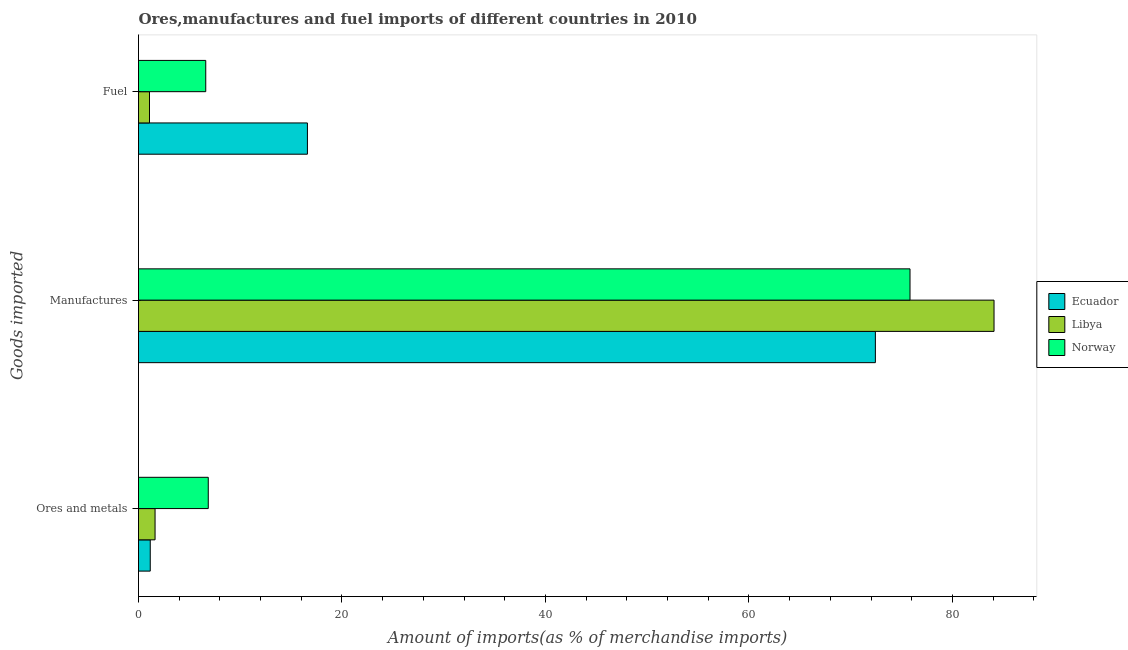How many different coloured bars are there?
Your answer should be very brief. 3. How many groups of bars are there?
Offer a terse response. 3. How many bars are there on the 2nd tick from the top?
Ensure brevity in your answer.  3. What is the label of the 2nd group of bars from the top?
Give a very brief answer. Manufactures. What is the percentage of ores and metals imports in Libya?
Your answer should be compact. 1.63. Across all countries, what is the maximum percentage of fuel imports?
Your answer should be compact. 16.6. Across all countries, what is the minimum percentage of manufactures imports?
Your answer should be very brief. 72.43. In which country was the percentage of fuel imports maximum?
Make the answer very short. Ecuador. In which country was the percentage of ores and metals imports minimum?
Make the answer very short. Ecuador. What is the total percentage of ores and metals imports in the graph?
Offer a very short reply. 9.64. What is the difference between the percentage of ores and metals imports in Libya and that in Ecuador?
Ensure brevity in your answer.  0.47. What is the difference between the percentage of manufactures imports in Libya and the percentage of fuel imports in Ecuador?
Offer a terse response. 67.49. What is the average percentage of manufactures imports per country?
Give a very brief answer. 77.45. What is the difference between the percentage of fuel imports and percentage of manufactures imports in Ecuador?
Your answer should be compact. -55.83. In how many countries, is the percentage of fuel imports greater than 16 %?
Give a very brief answer. 1. What is the ratio of the percentage of ores and metals imports in Ecuador to that in Libya?
Give a very brief answer. 0.71. Is the difference between the percentage of manufactures imports in Norway and Libya greater than the difference between the percentage of ores and metals imports in Norway and Libya?
Keep it short and to the point. No. What is the difference between the highest and the second highest percentage of fuel imports?
Give a very brief answer. 9.99. What is the difference between the highest and the lowest percentage of manufactures imports?
Ensure brevity in your answer.  11.66. In how many countries, is the percentage of manufactures imports greater than the average percentage of manufactures imports taken over all countries?
Make the answer very short. 1. What does the 2nd bar from the top in Ores and metals represents?
Give a very brief answer. Libya. What does the 1st bar from the bottom in Manufactures represents?
Provide a short and direct response. Ecuador. Is it the case that in every country, the sum of the percentage of ores and metals imports and percentage of manufactures imports is greater than the percentage of fuel imports?
Provide a short and direct response. Yes. Are all the bars in the graph horizontal?
Offer a very short reply. Yes. How many countries are there in the graph?
Offer a very short reply. 3. Are the values on the major ticks of X-axis written in scientific E-notation?
Provide a succinct answer. No. Does the graph contain grids?
Provide a short and direct response. No. How many legend labels are there?
Provide a short and direct response. 3. What is the title of the graph?
Offer a terse response. Ores,manufactures and fuel imports of different countries in 2010. Does "Niger" appear as one of the legend labels in the graph?
Make the answer very short. No. What is the label or title of the X-axis?
Offer a very short reply. Amount of imports(as % of merchandise imports). What is the label or title of the Y-axis?
Your response must be concise. Goods imported. What is the Amount of imports(as % of merchandise imports) of Ecuador in Ores and metals?
Offer a very short reply. 1.15. What is the Amount of imports(as % of merchandise imports) in Libya in Ores and metals?
Provide a short and direct response. 1.63. What is the Amount of imports(as % of merchandise imports) in Norway in Ores and metals?
Provide a short and direct response. 6.86. What is the Amount of imports(as % of merchandise imports) of Ecuador in Manufactures?
Provide a short and direct response. 72.43. What is the Amount of imports(as % of merchandise imports) of Libya in Manufactures?
Offer a terse response. 84.09. What is the Amount of imports(as % of merchandise imports) in Norway in Manufactures?
Offer a terse response. 75.83. What is the Amount of imports(as % of merchandise imports) in Ecuador in Fuel?
Ensure brevity in your answer.  16.6. What is the Amount of imports(as % of merchandise imports) in Libya in Fuel?
Provide a succinct answer. 1.08. What is the Amount of imports(as % of merchandise imports) in Norway in Fuel?
Your response must be concise. 6.61. Across all Goods imported, what is the maximum Amount of imports(as % of merchandise imports) in Ecuador?
Give a very brief answer. 72.43. Across all Goods imported, what is the maximum Amount of imports(as % of merchandise imports) of Libya?
Keep it short and to the point. 84.09. Across all Goods imported, what is the maximum Amount of imports(as % of merchandise imports) of Norway?
Offer a terse response. 75.83. Across all Goods imported, what is the minimum Amount of imports(as % of merchandise imports) in Ecuador?
Ensure brevity in your answer.  1.15. Across all Goods imported, what is the minimum Amount of imports(as % of merchandise imports) of Libya?
Ensure brevity in your answer.  1.08. Across all Goods imported, what is the minimum Amount of imports(as % of merchandise imports) of Norway?
Offer a terse response. 6.61. What is the total Amount of imports(as % of merchandise imports) of Ecuador in the graph?
Your response must be concise. 90.19. What is the total Amount of imports(as % of merchandise imports) in Libya in the graph?
Offer a very short reply. 86.8. What is the total Amount of imports(as % of merchandise imports) of Norway in the graph?
Your answer should be compact. 89.3. What is the difference between the Amount of imports(as % of merchandise imports) in Ecuador in Ores and metals and that in Manufactures?
Provide a succinct answer. -71.28. What is the difference between the Amount of imports(as % of merchandise imports) of Libya in Ores and metals and that in Manufactures?
Give a very brief answer. -82.47. What is the difference between the Amount of imports(as % of merchandise imports) in Norway in Ores and metals and that in Manufactures?
Your answer should be very brief. -68.98. What is the difference between the Amount of imports(as % of merchandise imports) of Ecuador in Ores and metals and that in Fuel?
Your answer should be compact. -15.45. What is the difference between the Amount of imports(as % of merchandise imports) of Libya in Ores and metals and that in Fuel?
Give a very brief answer. 0.55. What is the difference between the Amount of imports(as % of merchandise imports) in Norway in Ores and metals and that in Fuel?
Make the answer very short. 0.25. What is the difference between the Amount of imports(as % of merchandise imports) of Ecuador in Manufactures and that in Fuel?
Provide a succinct answer. 55.83. What is the difference between the Amount of imports(as % of merchandise imports) in Libya in Manufactures and that in Fuel?
Keep it short and to the point. 83.01. What is the difference between the Amount of imports(as % of merchandise imports) of Norway in Manufactures and that in Fuel?
Your answer should be very brief. 69.23. What is the difference between the Amount of imports(as % of merchandise imports) of Ecuador in Ores and metals and the Amount of imports(as % of merchandise imports) of Libya in Manufactures?
Provide a short and direct response. -82.94. What is the difference between the Amount of imports(as % of merchandise imports) in Ecuador in Ores and metals and the Amount of imports(as % of merchandise imports) in Norway in Manufactures?
Your answer should be very brief. -74.68. What is the difference between the Amount of imports(as % of merchandise imports) of Libya in Ores and metals and the Amount of imports(as % of merchandise imports) of Norway in Manufactures?
Your answer should be very brief. -74.21. What is the difference between the Amount of imports(as % of merchandise imports) in Ecuador in Ores and metals and the Amount of imports(as % of merchandise imports) in Libya in Fuel?
Ensure brevity in your answer.  0.07. What is the difference between the Amount of imports(as % of merchandise imports) in Ecuador in Ores and metals and the Amount of imports(as % of merchandise imports) in Norway in Fuel?
Make the answer very short. -5.46. What is the difference between the Amount of imports(as % of merchandise imports) in Libya in Ores and metals and the Amount of imports(as % of merchandise imports) in Norway in Fuel?
Provide a succinct answer. -4.98. What is the difference between the Amount of imports(as % of merchandise imports) of Ecuador in Manufactures and the Amount of imports(as % of merchandise imports) of Libya in Fuel?
Your answer should be very brief. 71.35. What is the difference between the Amount of imports(as % of merchandise imports) of Ecuador in Manufactures and the Amount of imports(as % of merchandise imports) of Norway in Fuel?
Ensure brevity in your answer.  65.82. What is the difference between the Amount of imports(as % of merchandise imports) in Libya in Manufactures and the Amount of imports(as % of merchandise imports) in Norway in Fuel?
Make the answer very short. 77.48. What is the average Amount of imports(as % of merchandise imports) in Ecuador per Goods imported?
Keep it short and to the point. 30.06. What is the average Amount of imports(as % of merchandise imports) in Libya per Goods imported?
Keep it short and to the point. 28.93. What is the average Amount of imports(as % of merchandise imports) of Norway per Goods imported?
Offer a terse response. 29.77. What is the difference between the Amount of imports(as % of merchandise imports) of Ecuador and Amount of imports(as % of merchandise imports) of Libya in Ores and metals?
Ensure brevity in your answer.  -0.47. What is the difference between the Amount of imports(as % of merchandise imports) in Ecuador and Amount of imports(as % of merchandise imports) in Norway in Ores and metals?
Keep it short and to the point. -5.7. What is the difference between the Amount of imports(as % of merchandise imports) of Libya and Amount of imports(as % of merchandise imports) of Norway in Ores and metals?
Provide a short and direct response. -5.23. What is the difference between the Amount of imports(as % of merchandise imports) in Ecuador and Amount of imports(as % of merchandise imports) in Libya in Manufactures?
Ensure brevity in your answer.  -11.66. What is the difference between the Amount of imports(as % of merchandise imports) of Ecuador and Amount of imports(as % of merchandise imports) of Norway in Manufactures?
Keep it short and to the point. -3.4. What is the difference between the Amount of imports(as % of merchandise imports) of Libya and Amount of imports(as % of merchandise imports) of Norway in Manufactures?
Your answer should be very brief. 8.26. What is the difference between the Amount of imports(as % of merchandise imports) in Ecuador and Amount of imports(as % of merchandise imports) in Libya in Fuel?
Provide a succinct answer. 15.52. What is the difference between the Amount of imports(as % of merchandise imports) in Ecuador and Amount of imports(as % of merchandise imports) in Norway in Fuel?
Provide a short and direct response. 9.99. What is the difference between the Amount of imports(as % of merchandise imports) in Libya and Amount of imports(as % of merchandise imports) in Norway in Fuel?
Your response must be concise. -5.53. What is the ratio of the Amount of imports(as % of merchandise imports) in Ecuador in Ores and metals to that in Manufactures?
Give a very brief answer. 0.02. What is the ratio of the Amount of imports(as % of merchandise imports) in Libya in Ores and metals to that in Manufactures?
Offer a terse response. 0.02. What is the ratio of the Amount of imports(as % of merchandise imports) of Norway in Ores and metals to that in Manufactures?
Your response must be concise. 0.09. What is the ratio of the Amount of imports(as % of merchandise imports) of Ecuador in Ores and metals to that in Fuel?
Provide a short and direct response. 0.07. What is the ratio of the Amount of imports(as % of merchandise imports) in Libya in Ores and metals to that in Fuel?
Offer a very short reply. 1.51. What is the ratio of the Amount of imports(as % of merchandise imports) in Norway in Ores and metals to that in Fuel?
Provide a short and direct response. 1.04. What is the ratio of the Amount of imports(as % of merchandise imports) of Ecuador in Manufactures to that in Fuel?
Your answer should be very brief. 4.36. What is the ratio of the Amount of imports(as % of merchandise imports) in Libya in Manufactures to that in Fuel?
Your answer should be compact. 77.82. What is the ratio of the Amount of imports(as % of merchandise imports) in Norway in Manufactures to that in Fuel?
Make the answer very short. 11.47. What is the difference between the highest and the second highest Amount of imports(as % of merchandise imports) of Ecuador?
Give a very brief answer. 55.83. What is the difference between the highest and the second highest Amount of imports(as % of merchandise imports) in Libya?
Provide a succinct answer. 82.47. What is the difference between the highest and the second highest Amount of imports(as % of merchandise imports) of Norway?
Offer a terse response. 68.98. What is the difference between the highest and the lowest Amount of imports(as % of merchandise imports) of Ecuador?
Offer a very short reply. 71.28. What is the difference between the highest and the lowest Amount of imports(as % of merchandise imports) of Libya?
Provide a succinct answer. 83.01. What is the difference between the highest and the lowest Amount of imports(as % of merchandise imports) of Norway?
Provide a short and direct response. 69.23. 